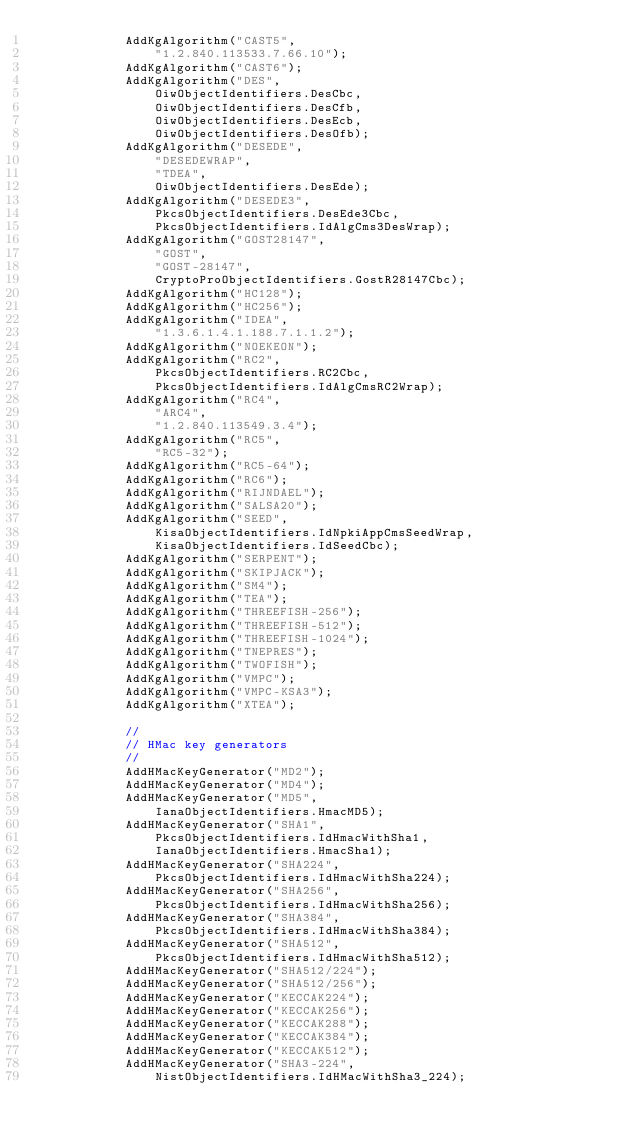Convert code to text. <code><loc_0><loc_0><loc_500><loc_500><_C#_>            AddKgAlgorithm("CAST5",
                "1.2.840.113533.7.66.10");
            AddKgAlgorithm("CAST6");
            AddKgAlgorithm("DES",
                OiwObjectIdentifiers.DesCbc,
                OiwObjectIdentifiers.DesCfb,
                OiwObjectIdentifiers.DesEcb,
                OiwObjectIdentifiers.DesOfb);
            AddKgAlgorithm("DESEDE",
                "DESEDEWRAP",
                "TDEA",
                OiwObjectIdentifiers.DesEde);
            AddKgAlgorithm("DESEDE3",
                PkcsObjectIdentifiers.DesEde3Cbc,
                PkcsObjectIdentifiers.IdAlgCms3DesWrap);
            AddKgAlgorithm("GOST28147",
                "GOST",
                "GOST-28147",
                CryptoProObjectIdentifiers.GostR28147Cbc);
            AddKgAlgorithm("HC128");
            AddKgAlgorithm("HC256");
            AddKgAlgorithm("IDEA",
                "1.3.6.1.4.1.188.7.1.1.2");
            AddKgAlgorithm("NOEKEON");
            AddKgAlgorithm("RC2",
                PkcsObjectIdentifiers.RC2Cbc,
                PkcsObjectIdentifiers.IdAlgCmsRC2Wrap);
            AddKgAlgorithm("RC4",
                "ARC4",
                "1.2.840.113549.3.4");
            AddKgAlgorithm("RC5",
                "RC5-32");
            AddKgAlgorithm("RC5-64");
            AddKgAlgorithm("RC6");
            AddKgAlgorithm("RIJNDAEL");
            AddKgAlgorithm("SALSA20");
            AddKgAlgorithm("SEED",
                KisaObjectIdentifiers.IdNpkiAppCmsSeedWrap,
                KisaObjectIdentifiers.IdSeedCbc);
            AddKgAlgorithm("SERPENT");
            AddKgAlgorithm("SKIPJACK");
            AddKgAlgorithm("SM4");
            AddKgAlgorithm("TEA");
            AddKgAlgorithm("THREEFISH-256");
            AddKgAlgorithm("THREEFISH-512");
            AddKgAlgorithm("THREEFISH-1024");
            AddKgAlgorithm("TNEPRES");
            AddKgAlgorithm("TWOFISH");
            AddKgAlgorithm("VMPC");
            AddKgAlgorithm("VMPC-KSA3");
            AddKgAlgorithm("XTEA");

            //
            // HMac key generators
            //
            AddHMacKeyGenerator("MD2");
            AddHMacKeyGenerator("MD4");
            AddHMacKeyGenerator("MD5",
                IanaObjectIdentifiers.HmacMD5);
            AddHMacKeyGenerator("SHA1",
                PkcsObjectIdentifiers.IdHmacWithSha1,
                IanaObjectIdentifiers.HmacSha1);
            AddHMacKeyGenerator("SHA224",
                PkcsObjectIdentifiers.IdHmacWithSha224);
            AddHMacKeyGenerator("SHA256",
                PkcsObjectIdentifiers.IdHmacWithSha256);
            AddHMacKeyGenerator("SHA384",
                PkcsObjectIdentifiers.IdHmacWithSha384);
            AddHMacKeyGenerator("SHA512",
                PkcsObjectIdentifiers.IdHmacWithSha512);
            AddHMacKeyGenerator("SHA512/224");
            AddHMacKeyGenerator("SHA512/256");
            AddHMacKeyGenerator("KECCAK224");
            AddHMacKeyGenerator("KECCAK256");
            AddHMacKeyGenerator("KECCAK288");
            AddHMacKeyGenerator("KECCAK384");
            AddHMacKeyGenerator("KECCAK512");
            AddHMacKeyGenerator("SHA3-224",
                NistObjectIdentifiers.IdHMacWithSha3_224);</code> 